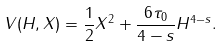<formula> <loc_0><loc_0><loc_500><loc_500>V ( H , X ) = \frac { 1 } { 2 } X ^ { 2 } + \frac { 6 \tau _ { 0 } } { 4 - s } H ^ { 4 - s } .</formula> 